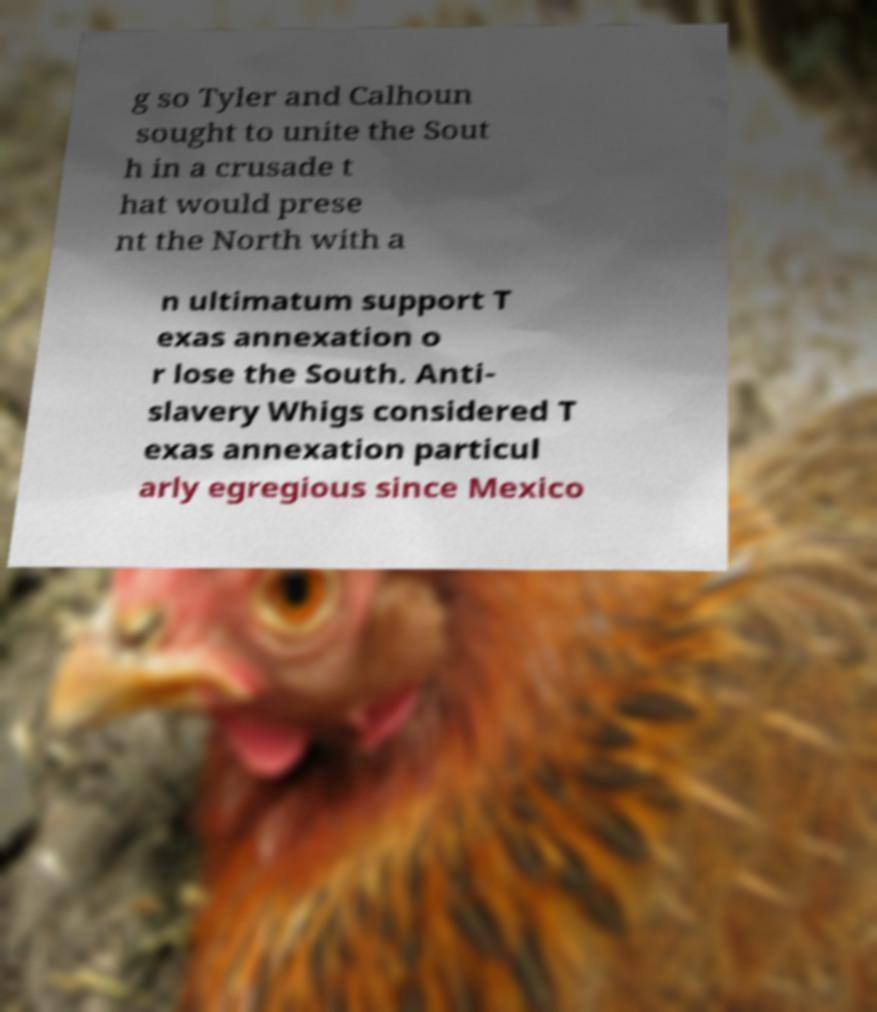I need the written content from this picture converted into text. Can you do that? g so Tyler and Calhoun sought to unite the Sout h in a crusade t hat would prese nt the North with a n ultimatum support T exas annexation o r lose the South. Anti- slavery Whigs considered T exas annexation particul arly egregious since Mexico 